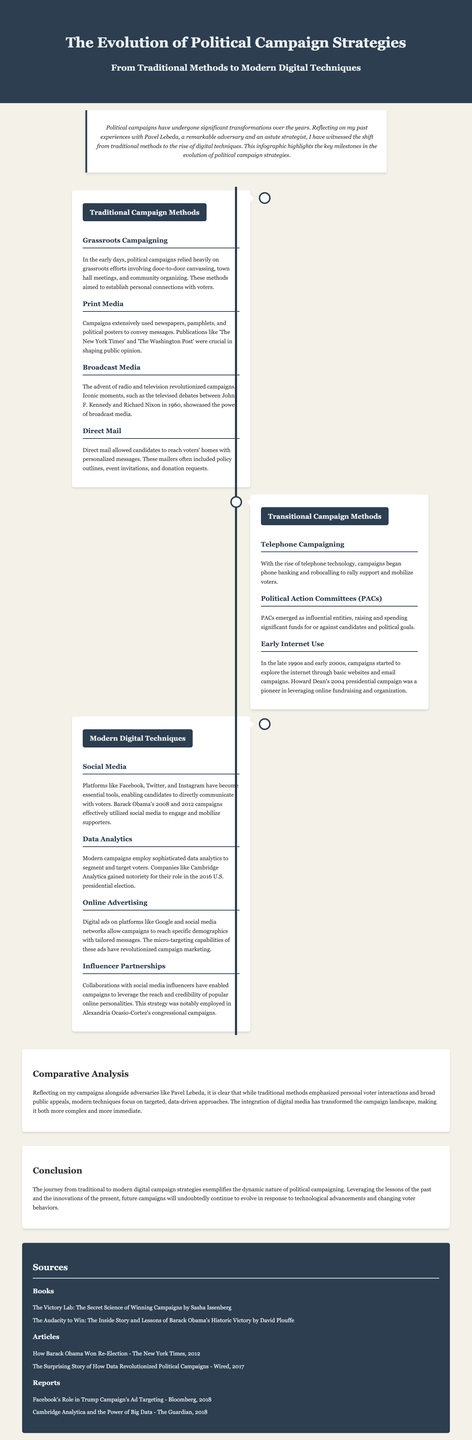what were the early campaign methods focused on? Early campaign methods focused on grassroots efforts, which included door-to-door canvassing and community organizing to establish personal connections with voters.
Answer: grassroots efforts what famous debates showcased the power of broadcast media? The televised debates between John F. Kennedy and Richard Nixon in 1960 are highlighted as iconic moments that showcased broadcast media's power.
Answer: Kennedy and Nixon debates what significant change did Howard Dean's campaign represent? Howard Dean's 2004 presidential campaign was notable for pioneering the use of online fundraising and organization in political campaigns.
Answer: online fundraising which social media platforms are mentioned as essential tools for modern campaigns? The infographic mentions Facebook, Twitter, and Instagram as essential tools for modern political campaigns.
Answer: Facebook, Twitter, Instagram how did modern campaigns utilize data analytics? Modern campaigns employ sophisticated data analytics to segment and target voters to tailor their messages effectively.
Answer: segment and target voters who collaborated with social media influencers during their campaign? Alexandria Ocasio-Cortez's congressional campaigns notably employed collaborations with social media influencers.
Answer: Alexandria Ocasio-Cortez what type of document is this? This document is an infographic that illustrates the evolution of political campaign strategies from traditional methods to modern digital techniques.
Answer: infographic how did the analysis section compare traditional and modern methods? The analysis section reflects that traditional methods emphasized personal interactions, while modern methods focus on targeted, data-driven approaches.
Answer: personal interactions vs. targeted methods what has changed about political campaigning over time? The document states that political campaigns have shifted from traditional methods to modern digital techniques, signifying a dynamic evolution.
Answer: modern digital techniques 